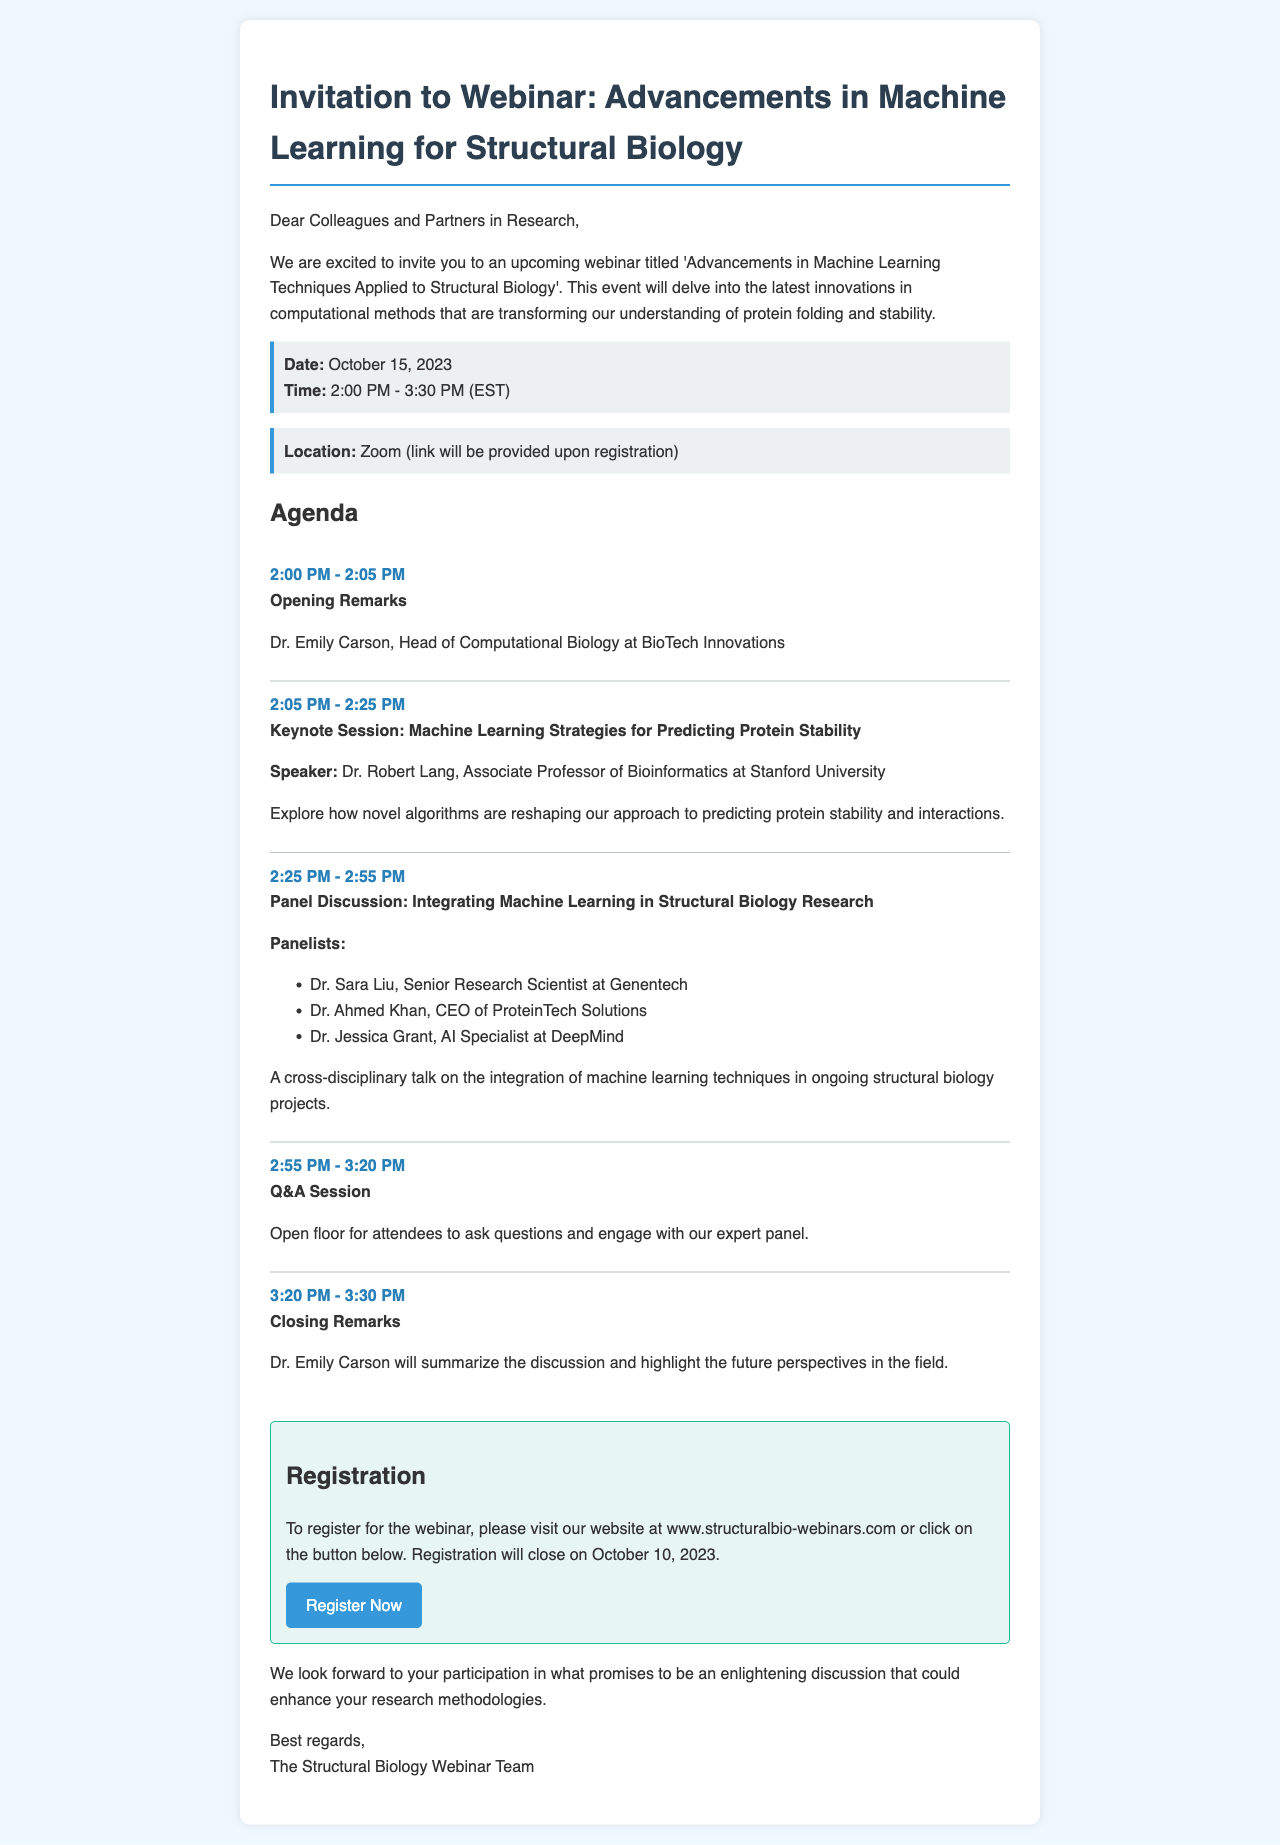what is the title of the webinar? The title of the webinar is given in the opening paragraph of the document.
Answer: Advancements in Machine Learning Techniques Applied to Structural Biology who is the keynote speaker? The keynote speaker is listed in the agenda section of the document.
Answer: Dr. Robert Lang what date is the webinar scheduled? The date of the webinar is explicitly mentioned in the date-time section of the document.
Answer: October 15, 2023 what time does the webinar start? The start time of the webinar is indicated in the date-time section of the document.
Answer: 2:00 PM how long is the webinar scheduled to last? The total duration of the webinar can be calculated from the starting and ending times provided in the date-time section.
Answer: 1 hour 30 minutes how many panelists are in the panel discussion? The number of panelists can be counted based on the names listed in the agenda item for the panel discussion.
Answer: 3 what is the registration deadline for the webinar? The deadline for registration is mentioned in the registration section of the document.
Answer: October 10, 2023 what platform will the webinar be hosted on? The platform for the webinar is specified in the location section of the document.
Answer: Zoom who will give the opening remarks? The person responsible for giving the opening remarks is mentioned next to the agenda item for opening remarks.
Answer: Dr. Emily Carson 